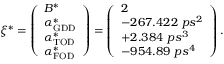<formula> <loc_0><loc_0><loc_500><loc_500>\xi ^ { * } = \left ( \begin{array} { l } { B ^ { * } } \\ { \alpha _ { G D D } ^ { * } } \\ { \alpha _ { T O D } ^ { * } } \\ { \alpha _ { F O D } ^ { * } } \end{array} \right ) = \left ( \begin{array} { l } { 2 } \\ { - 2 6 7 . 4 2 2 \ p s ^ { 2 } } \\ { + 2 . 3 8 4 \ p s ^ { 3 } } \\ { - 9 5 4 . 8 9 \ p s ^ { 4 } } \end{array} \right ) .</formula> 